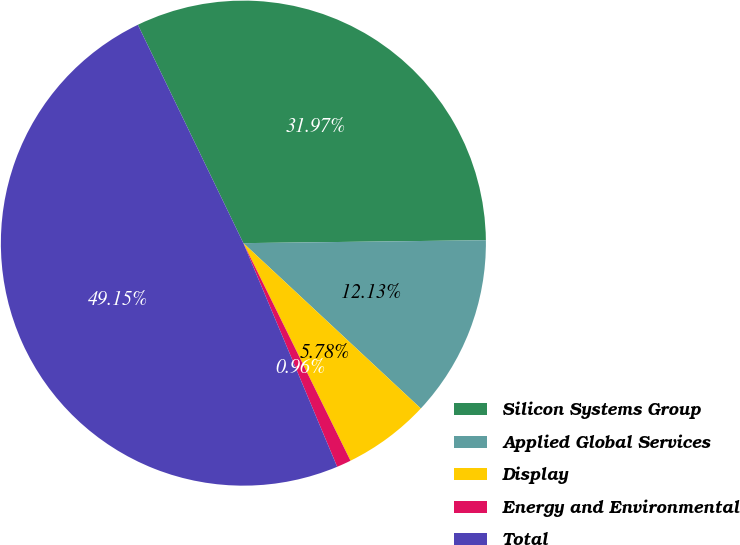Convert chart to OTSL. <chart><loc_0><loc_0><loc_500><loc_500><pie_chart><fcel>Silicon Systems Group<fcel>Applied Global Services<fcel>Display<fcel>Energy and Environmental<fcel>Total<nl><fcel>31.97%<fcel>12.13%<fcel>5.78%<fcel>0.96%<fcel>49.15%<nl></chart> 